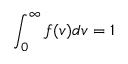Convert formula to latex. <formula><loc_0><loc_0><loc_500><loc_500>\int _ { 0 } ^ { \infty } f ( v ) d v = 1</formula> 